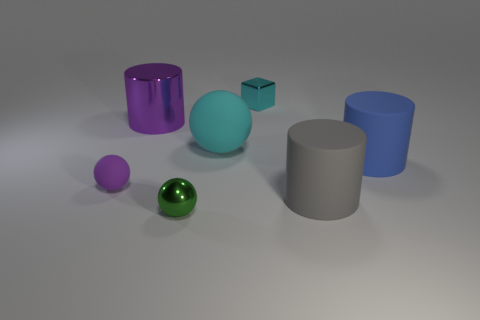Add 1 shiny cylinders. How many objects exist? 8 Subtract all spheres. How many objects are left? 4 Add 5 big metallic things. How many big metallic things are left? 6 Add 1 yellow rubber cylinders. How many yellow rubber cylinders exist? 1 Subtract 0 green cylinders. How many objects are left? 7 Subtract all gray objects. Subtract all cyan metallic objects. How many objects are left? 5 